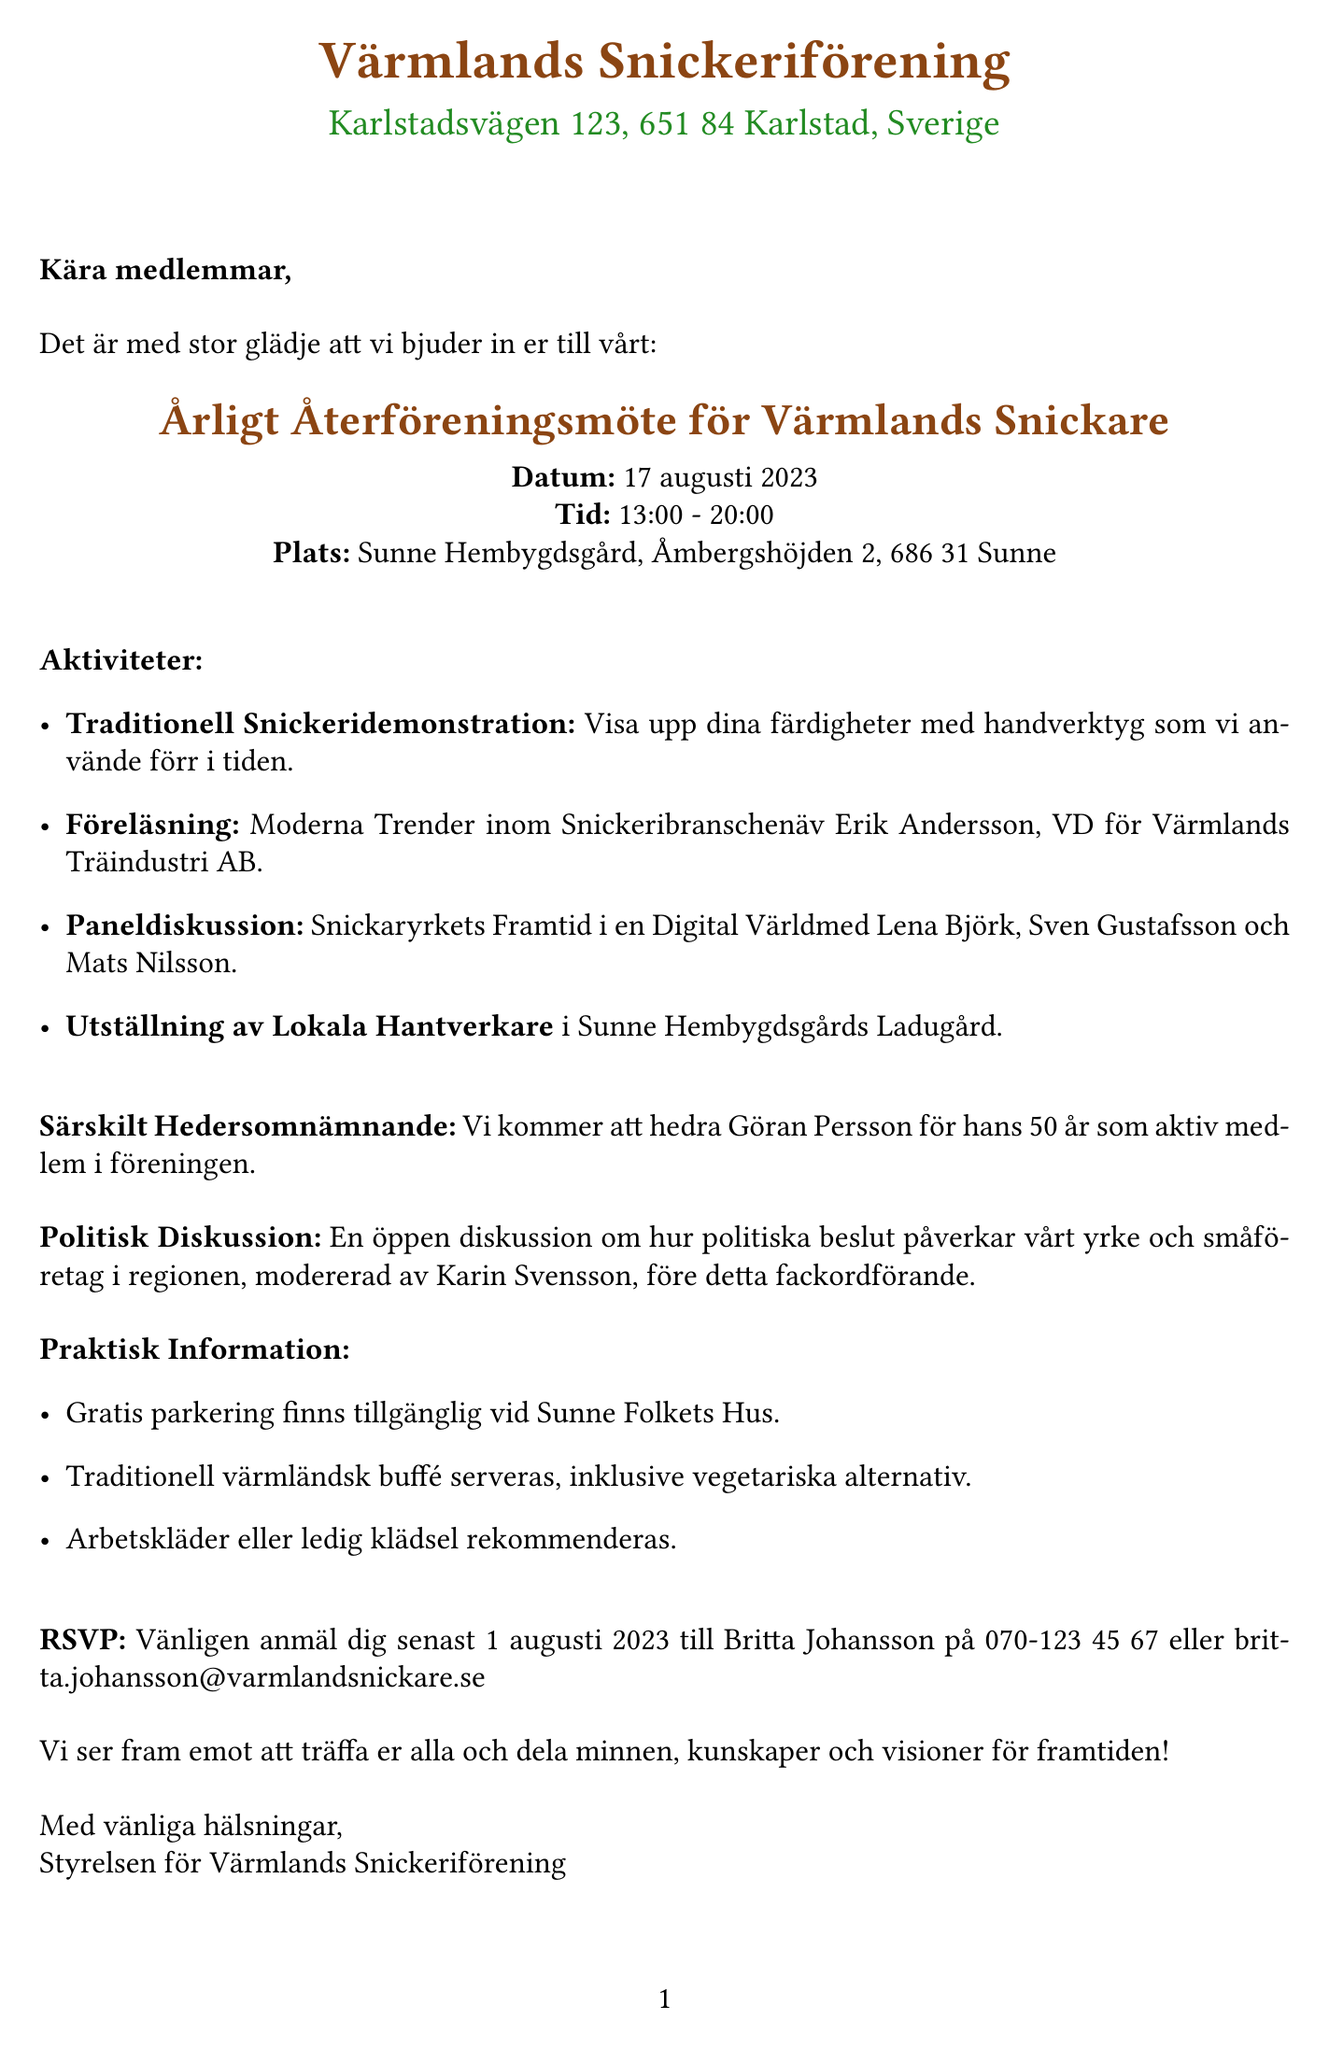Vad är namnet på evenemanget? Evenemangets namn anges tydligt i dokumentet som "Årligt Återföreningsmöte för Värmlands Snickare".
Answer: Årligt Återföreningsmöte för Värmlands Snickare När äger evenemanget rum? Datumet för evenemanget är specificerat som "17 augusti 2023".
Answer: 17 augusti 2023 Vilka är namnen på deltagarna i paneldiskussionen? Deltagarna i paneldiskussionen listas i dokumentet som Lena Björk, Sven Gustafsson och Mats Nilsson.
Answer: Lena Björk, Sven Gustafsson, Mats Nilsson Vad är ämnet för den politiska diskussionen? Ämnet för diskussionen beskrivs som "Diskussion om Arbetsmarknadsreformer".
Answer: Diskussion om Arbetsmarknadsreformer Vem kommer att få ett särskilt hedersomnämnande? Dokumentet nämner att Göran Persson kommer att hedra för sin tid som medlem.
Answer: Göran Persson Vad rekommenderas som klädsel? Klädseln som rekommenderas anges tydligt som "Arbetskläder eller ledig klädsel".
Answer: Arbetskläder eller ledig klädsel Vad är kontaktuppgifterna för att anmäla sig? Kontaktinformationen för anmälan ges i dokumentet som inkluderar ett namn och telefonnummer samt e-postadress.
Answer: Britta Johansson på 070-123 45 67 eller britta.johansson@varmlandsnickare.se Finns det parkering tillgänglig? Informationen angående parkering är tydlig och anger att gratis parkering finns tillgänglig.
Answer: Gratis parkering finns tillgänglig Vilken tid börjar evenemanget? Starttiden för evenemanget specificeras som "13:00".
Answer: 13:00 